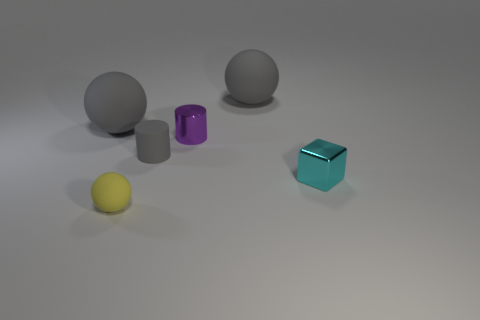Are there any other things that have the same color as the rubber cylinder?
Offer a terse response. Yes. There is a cylinder in front of the purple shiny thing; does it have the same color as the small rubber object in front of the tiny cyan thing?
Provide a succinct answer. No. Are there any large cyan shiny blocks?
Your response must be concise. No. Are there any brown spheres that have the same material as the purple cylinder?
Your response must be concise. No. Is there any other thing that is the same material as the tiny block?
Your answer should be very brief. Yes. What is the color of the tiny rubber cylinder?
Offer a very short reply. Gray. What color is the shiny cube that is the same size as the purple metal thing?
Provide a succinct answer. Cyan. How many rubber objects are either gray spheres or tiny purple objects?
Provide a short and direct response. 2. What number of tiny objects are on the left side of the tiny shiny cube and behind the tiny yellow matte sphere?
Make the answer very short. 2. Is there anything else that is the same shape as the tiny cyan metal object?
Offer a very short reply. No. 